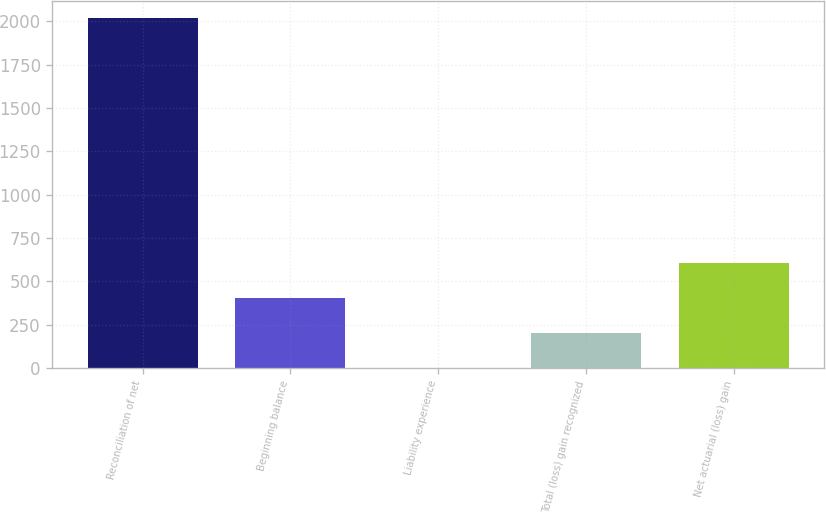Convert chart to OTSL. <chart><loc_0><loc_0><loc_500><loc_500><bar_chart><fcel>Reconciliation of net<fcel>Beginning balance<fcel>Liability experience<fcel>Total (loss) gain recognized<fcel>Net actuarial (loss) gain<nl><fcel>2018<fcel>404.4<fcel>1<fcel>202.7<fcel>606.1<nl></chart> 